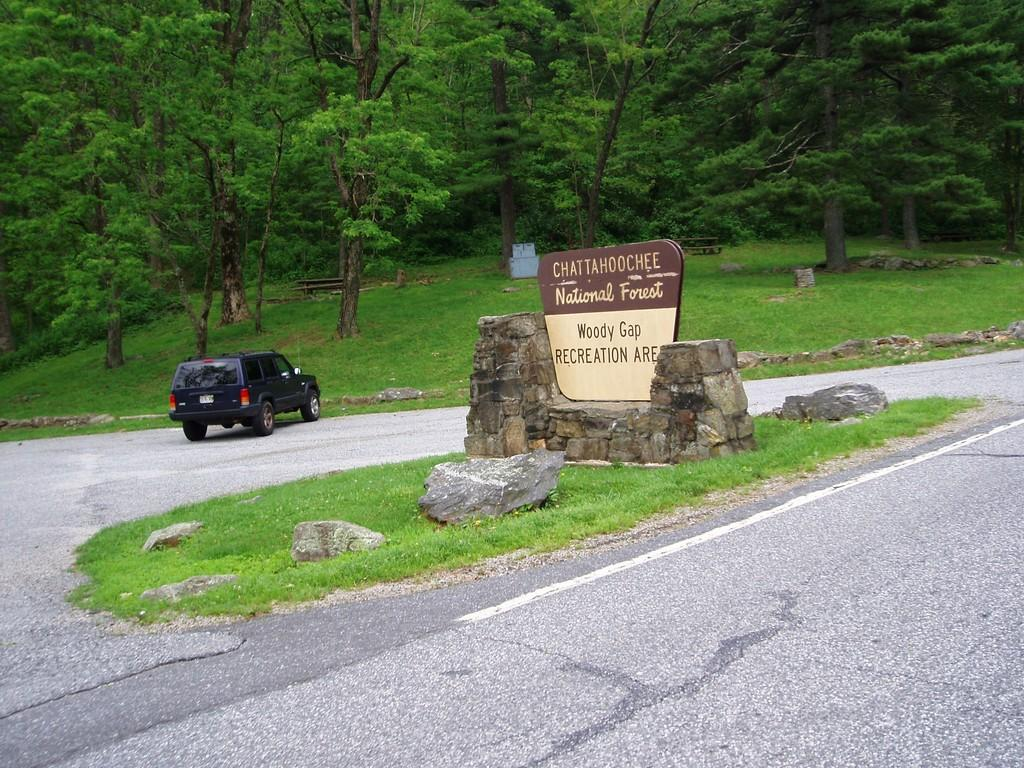What type of vegetation can be seen in the background of the image? There are trees and grass in the background of the image. What is located on a stone platform in the image? There is a board on a stone platform. What type of surface is visible in the image? There is a road in the image. Is there any transportation visible in the image? Yes, there is a vehicle on the road. What type of stone is the police officer using to transport goods in the image? There is no police officer or stone present in the image, and therefore no such activity can be observed. 